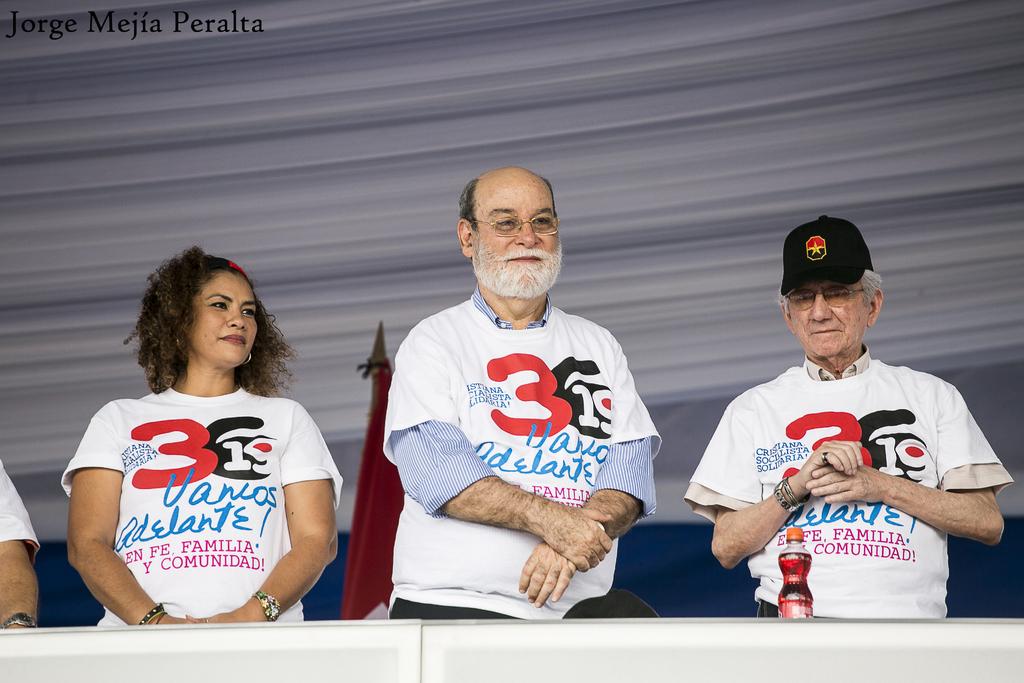What number is in red?
Make the answer very short. 3. 